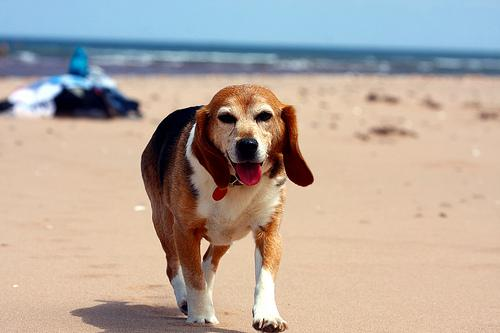Question: what color is the sand?
Choices:
A. Red.
B. White.
C. Black.
D. Beige.
Answer with the letter. Answer: D Question: where was this photo taken?
Choices:
A. At the beach.
B. Church.
C. School.
D. Zoo.
Answer with the letter. Answer: A Question: when was this photo taken?
Choices:
A. Sunset.
B. Midnight.
C. Dawn.
D. Outside, during the daytime.
Answer with the letter. Answer: D Question: how many ears are visible on this dog?
Choices:
A. One.
B. Three.
C. Four.
D. Two.
Answer with the letter. Answer: D 